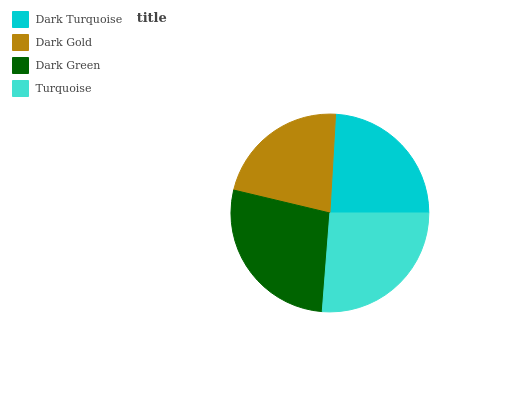Is Dark Gold the minimum?
Answer yes or no. Yes. Is Dark Green the maximum?
Answer yes or no. Yes. Is Dark Green the minimum?
Answer yes or no. No. Is Dark Gold the maximum?
Answer yes or no. No. Is Dark Green greater than Dark Gold?
Answer yes or no. Yes. Is Dark Gold less than Dark Green?
Answer yes or no. Yes. Is Dark Gold greater than Dark Green?
Answer yes or no. No. Is Dark Green less than Dark Gold?
Answer yes or no. No. Is Turquoise the high median?
Answer yes or no. Yes. Is Dark Turquoise the low median?
Answer yes or no. Yes. Is Dark Green the high median?
Answer yes or no. No. Is Dark Gold the low median?
Answer yes or no. No. 